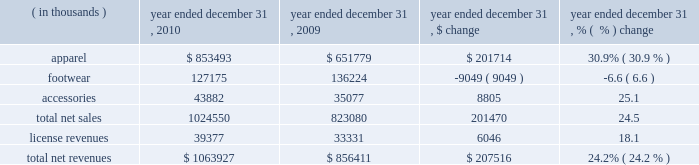Year ended december 31 , 2010 compared to year ended december 31 , 2009 net revenues increased $ 207.5 million , or 24.2% ( 24.2 % ) , to $ 1063.9 million in 2010 from $ 856.4 million in 2009 .
Net revenues by product category are summarized below: .
Net sales increased $ 201.5 million , or 24.5% ( 24.5 % ) , to $ 1024.6 million in 2010 from $ 823.1 million in 2009 as noted in the table above .
The increase in net sales primarily reflects : 2022 $ 88.9 million , or 56.8% ( 56.8 % ) , increase in direct to consumer sales , which includes 19 additional stores in 2010 ; and 2022 unit growth driven by increased distribution and new offerings in multiple product categories , most significantly in our training , base layer , mountain , golf and underwear categories ; partially offset by 2022 $ 9.0 million decrease in footwear sales driven primarily by a decline in running and training footwear sales .
License revenues increased $ 6.1 million , or 18.1% ( 18.1 % ) , to $ 39.4 million in 2010 from $ 33.3 million in 2009 .
This increase in license revenues was primarily a result of increased sales by our licensees due to increased distribution and continued unit volume growth .
We have developed our own headwear and bags , and beginning in 2011 , these products are being sold by us rather than by one of our licensees .
Gross profit increased $ 120.4 million to $ 530.5 million in 2010 from $ 410.1 million in 2009 .
Gross profit as a percentage of net revenues , or gross margin , increased 200 basis points to 49.9% ( 49.9 % ) in 2010 compared to 47.9% ( 47.9 % ) in 2009 .
The increase in gross margin percentage was primarily driven by the following : 2022 approximate 100 basis point increase driven by increased direct to consumer higher margin sales ; 2022 approximate 50 basis point increase driven by decreased sales markdowns and returns , primarily due to improved sell-through rates at retail ; and 2022 approximate 50 basis point increase driven primarily by liquidation sales and related inventory reserve reversals .
The current year period benefited from reversals of inventory reserves established in the prior year relative to certain cleated footwear , sport specific apparel and gloves .
These products have historically been more difficult to liquidate at favorable prices .
Selling , general and administrative expenses increased $ 93.3 million to $ 418.2 million in 2010 from $ 324.9 million in 2009 .
As a percentage of net revenues , selling , general and administrative expenses increased to 39.3% ( 39.3 % ) in 2010 from 37.9% ( 37.9 % ) in 2009 .
These changes were primarily attributable to the following : 2022 marketing costs increased $ 19.3 million to $ 128.2 million in 2010 from $ 108.9 million in 2009 primarily due to an increase in sponsorship of events and collegiate and professional teams and athletes , increased television and digital campaign costs , including media campaigns for specific customers and additional personnel costs .
In addition , we incurred increased expenses for our performance incentive plan as compared to the prior year .
As a percentage of net revenues , marketing costs decreased to 12.0% ( 12.0 % ) in 2010 from 12.7% ( 12.7 % ) in 2009 primarily due to decreased marketing costs for specific customers. .
In 2010 what was the percent of the apparel sales as part of the net sales? 
Computations: (853493 / 1063927)
Answer: 0.80221. 